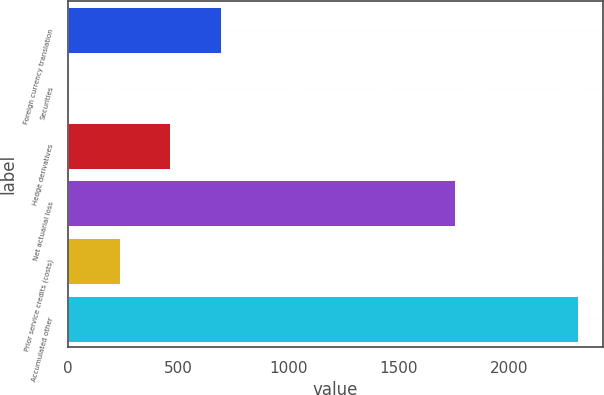Convert chart. <chart><loc_0><loc_0><loc_500><loc_500><bar_chart><fcel>Foreign currency translation<fcel>Securities<fcel>Hedge derivatives<fcel>Net actuarial loss<fcel>Prior service credits (costs)<fcel>Accumulated other<nl><fcel>695.8<fcel>3.7<fcel>465.1<fcel>1756.1<fcel>234.4<fcel>2310.7<nl></chart> 